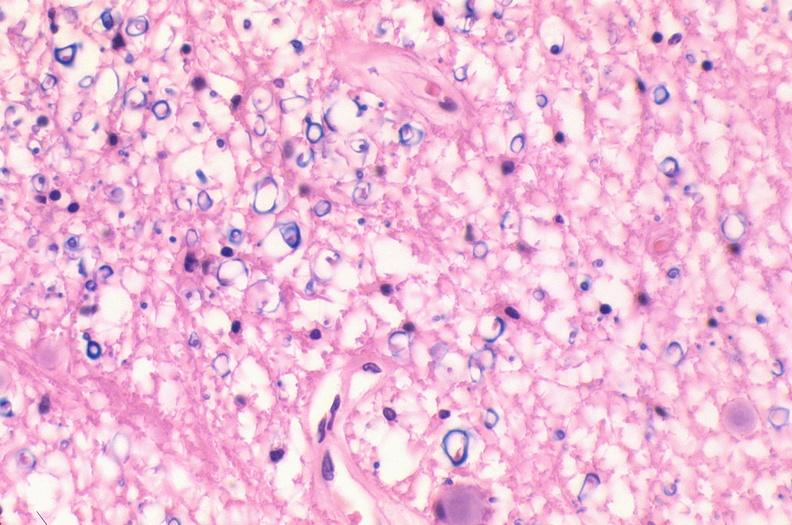s left ventricle hypertrophy present?
Answer the question using a single word or phrase. No 